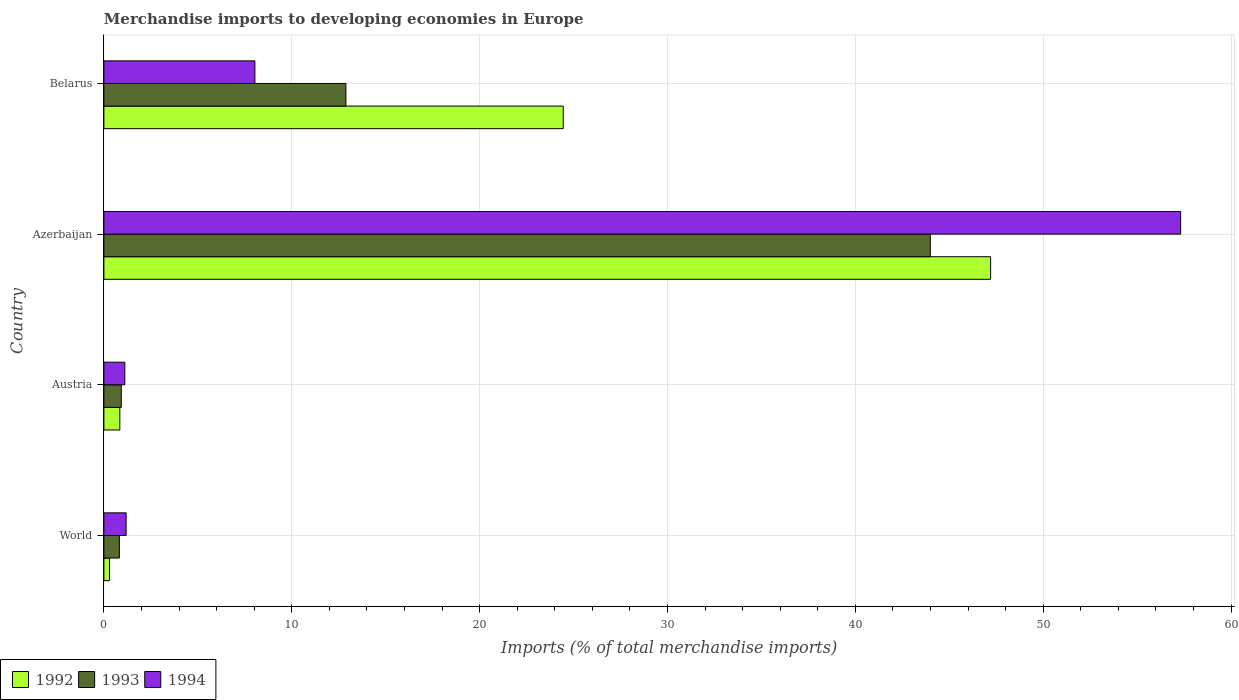How many groups of bars are there?
Make the answer very short. 4. Are the number of bars on each tick of the Y-axis equal?
Your response must be concise. Yes. How many bars are there on the 2nd tick from the top?
Provide a short and direct response. 3. How many bars are there on the 3rd tick from the bottom?
Make the answer very short. 3. In how many cases, is the number of bars for a given country not equal to the number of legend labels?
Keep it short and to the point. 0. What is the percentage total merchandise imports in 1993 in Belarus?
Keep it short and to the point. 12.88. Across all countries, what is the maximum percentage total merchandise imports in 1994?
Your answer should be compact. 57.31. Across all countries, what is the minimum percentage total merchandise imports in 1994?
Keep it short and to the point. 1.11. In which country was the percentage total merchandise imports in 1994 maximum?
Give a very brief answer. Azerbaijan. What is the total percentage total merchandise imports in 1992 in the graph?
Give a very brief answer. 72.8. What is the difference between the percentage total merchandise imports in 1993 in Azerbaijan and that in Belarus?
Offer a very short reply. 31.11. What is the difference between the percentage total merchandise imports in 1993 in Belarus and the percentage total merchandise imports in 1992 in Austria?
Your answer should be compact. 12.03. What is the average percentage total merchandise imports in 1993 per country?
Give a very brief answer. 14.65. What is the difference between the percentage total merchandise imports in 1994 and percentage total merchandise imports in 1993 in Azerbaijan?
Keep it short and to the point. 13.33. In how many countries, is the percentage total merchandise imports in 1994 greater than 8 %?
Give a very brief answer. 2. What is the ratio of the percentage total merchandise imports in 1994 in Austria to that in Azerbaijan?
Offer a very short reply. 0.02. Is the percentage total merchandise imports in 1992 in Azerbaijan less than that in Belarus?
Provide a succinct answer. No. What is the difference between the highest and the second highest percentage total merchandise imports in 1994?
Give a very brief answer. 49.28. What is the difference between the highest and the lowest percentage total merchandise imports in 1992?
Provide a succinct answer. 46.9. In how many countries, is the percentage total merchandise imports in 1994 greater than the average percentage total merchandise imports in 1994 taken over all countries?
Your answer should be very brief. 1. What does the 2nd bar from the bottom in Azerbaijan represents?
Ensure brevity in your answer.  1993. Is it the case that in every country, the sum of the percentage total merchandise imports in 1994 and percentage total merchandise imports in 1992 is greater than the percentage total merchandise imports in 1993?
Give a very brief answer. Yes. How many countries are there in the graph?
Your answer should be very brief. 4. What is the difference between two consecutive major ticks on the X-axis?
Ensure brevity in your answer.  10. Does the graph contain any zero values?
Give a very brief answer. No. Does the graph contain grids?
Provide a succinct answer. Yes. Where does the legend appear in the graph?
Provide a succinct answer. Bottom left. How many legend labels are there?
Make the answer very short. 3. How are the legend labels stacked?
Provide a short and direct response. Horizontal. What is the title of the graph?
Keep it short and to the point. Merchandise imports to developing economies in Europe. Does "1975" appear as one of the legend labels in the graph?
Your answer should be compact. No. What is the label or title of the X-axis?
Offer a very short reply. Imports (% of total merchandise imports). What is the label or title of the Y-axis?
Offer a terse response. Country. What is the Imports (% of total merchandise imports) in 1992 in World?
Offer a very short reply. 0.3. What is the Imports (% of total merchandise imports) in 1993 in World?
Give a very brief answer. 0.82. What is the Imports (% of total merchandise imports) of 1994 in World?
Provide a succinct answer. 1.18. What is the Imports (% of total merchandise imports) in 1992 in Austria?
Offer a very short reply. 0.85. What is the Imports (% of total merchandise imports) of 1993 in Austria?
Your answer should be compact. 0.93. What is the Imports (% of total merchandise imports) of 1994 in Austria?
Keep it short and to the point. 1.11. What is the Imports (% of total merchandise imports) in 1992 in Azerbaijan?
Offer a terse response. 47.2. What is the Imports (% of total merchandise imports) in 1993 in Azerbaijan?
Your response must be concise. 43.99. What is the Imports (% of total merchandise imports) of 1994 in Azerbaijan?
Provide a succinct answer. 57.31. What is the Imports (% of total merchandise imports) in 1992 in Belarus?
Your answer should be compact. 24.45. What is the Imports (% of total merchandise imports) in 1993 in Belarus?
Your answer should be very brief. 12.88. What is the Imports (% of total merchandise imports) in 1994 in Belarus?
Make the answer very short. 8.04. Across all countries, what is the maximum Imports (% of total merchandise imports) of 1992?
Offer a very short reply. 47.2. Across all countries, what is the maximum Imports (% of total merchandise imports) in 1993?
Keep it short and to the point. 43.99. Across all countries, what is the maximum Imports (% of total merchandise imports) of 1994?
Your response must be concise. 57.31. Across all countries, what is the minimum Imports (% of total merchandise imports) of 1992?
Make the answer very short. 0.3. Across all countries, what is the minimum Imports (% of total merchandise imports) of 1993?
Your answer should be very brief. 0.82. Across all countries, what is the minimum Imports (% of total merchandise imports) in 1994?
Keep it short and to the point. 1.11. What is the total Imports (% of total merchandise imports) of 1992 in the graph?
Provide a short and direct response. 72.8. What is the total Imports (% of total merchandise imports) in 1993 in the graph?
Keep it short and to the point. 58.62. What is the total Imports (% of total merchandise imports) of 1994 in the graph?
Offer a very short reply. 67.65. What is the difference between the Imports (% of total merchandise imports) of 1992 in World and that in Austria?
Your answer should be compact. -0.55. What is the difference between the Imports (% of total merchandise imports) of 1993 in World and that in Austria?
Ensure brevity in your answer.  -0.1. What is the difference between the Imports (% of total merchandise imports) of 1994 in World and that in Austria?
Ensure brevity in your answer.  0.07. What is the difference between the Imports (% of total merchandise imports) of 1992 in World and that in Azerbaijan?
Give a very brief answer. -46.9. What is the difference between the Imports (% of total merchandise imports) in 1993 in World and that in Azerbaijan?
Give a very brief answer. -43.16. What is the difference between the Imports (% of total merchandise imports) of 1994 in World and that in Azerbaijan?
Offer a very short reply. -56.13. What is the difference between the Imports (% of total merchandise imports) of 1992 in World and that in Belarus?
Make the answer very short. -24.15. What is the difference between the Imports (% of total merchandise imports) of 1993 in World and that in Belarus?
Keep it short and to the point. -12.06. What is the difference between the Imports (% of total merchandise imports) of 1994 in World and that in Belarus?
Make the answer very short. -6.85. What is the difference between the Imports (% of total merchandise imports) of 1992 in Austria and that in Azerbaijan?
Ensure brevity in your answer.  -46.35. What is the difference between the Imports (% of total merchandise imports) in 1993 in Austria and that in Azerbaijan?
Provide a succinct answer. -43.06. What is the difference between the Imports (% of total merchandise imports) in 1994 in Austria and that in Azerbaijan?
Your answer should be very brief. -56.2. What is the difference between the Imports (% of total merchandise imports) of 1992 in Austria and that in Belarus?
Give a very brief answer. -23.6. What is the difference between the Imports (% of total merchandise imports) in 1993 in Austria and that in Belarus?
Your response must be concise. -11.95. What is the difference between the Imports (% of total merchandise imports) in 1994 in Austria and that in Belarus?
Provide a succinct answer. -6.92. What is the difference between the Imports (% of total merchandise imports) in 1992 in Azerbaijan and that in Belarus?
Keep it short and to the point. 22.75. What is the difference between the Imports (% of total merchandise imports) of 1993 in Azerbaijan and that in Belarus?
Keep it short and to the point. 31.11. What is the difference between the Imports (% of total merchandise imports) of 1994 in Azerbaijan and that in Belarus?
Make the answer very short. 49.28. What is the difference between the Imports (% of total merchandise imports) of 1992 in World and the Imports (% of total merchandise imports) of 1993 in Austria?
Keep it short and to the point. -0.63. What is the difference between the Imports (% of total merchandise imports) in 1992 in World and the Imports (% of total merchandise imports) in 1994 in Austria?
Make the answer very short. -0.81. What is the difference between the Imports (% of total merchandise imports) of 1993 in World and the Imports (% of total merchandise imports) of 1994 in Austria?
Make the answer very short. -0.29. What is the difference between the Imports (% of total merchandise imports) of 1992 in World and the Imports (% of total merchandise imports) of 1993 in Azerbaijan?
Your response must be concise. -43.69. What is the difference between the Imports (% of total merchandise imports) in 1992 in World and the Imports (% of total merchandise imports) in 1994 in Azerbaijan?
Make the answer very short. -57.01. What is the difference between the Imports (% of total merchandise imports) in 1993 in World and the Imports (% of total merchandise imports) in 1994 in Azerbaijan?
Offer a very short reply. -56.49. What is the difference between the Imports (% of total merchandise imports) of 1992 in World and the Imports (% of total merchandise imports) of 1993 in Belarus?
Your response must be concise. -12.58. What is the difference between the Imports (% of total merchandise imports) in 1992 in World and the Imports (% of total merchandise imports) in 1994 in Belarus?
Provide a short and direct response. -7.74. What is the difference between the Imports (% of total merchandise imports) in 1993 in World and the Imports (% of total merchandise imports) in 1994 in Belarus?
Your answer should be very brief. -7.21. What is the difference between the Imports (% of total merchandise imports) of 1992 in Austria and the Imports (% of total merchandise imports) of 1993 in Azerbaijan?
Ensure brevity in your answer.  -43.14. What is the difference between the Imports (% of total merchandise imports) in 1992 in Austria and the Imports (% of total merchandise imports) in 1994 in Azerbaijan?
Your answer should be compact. -56.46. What is the difference between the Imports (% of total merchandise imports) of 1993 in Austria and the Imports (% of total merchandise imports) of 1994 in Azerbaijan?
Provide a short and direct response. -56.39. What is the difference between the Imports (% of total merchandise imports) of 1992 in Austria and the Imports (% of total merchandise imports) of 1993 in Belarus?
Provide a succinct answer. -12.03. What is the difference between the Imports (% of total merchandise imports) of 1992 in Austria and the Imports (% of total merchandise imports) of 1994 in Belarus?
Ensure brevity in your answer.  -7.19. What is the difference between the Imports (% of total merchandise imports) of 1993 in Austria and the Imports (% of total merchandise imports) of 1994 in Belarus?
Your answer should be very brief. -7.11. What is the difference between the Imports (% of total merchandise imports) of 1992 in Azerbaijan and the Imports (% of total merchandise imports) of 1993 in Belarus?
Offer a terse response. 34.32. What is the difference between the Imports (% of total merchandise imports) in 1992 in Azerbaijan and the Imports (% of total merchandise imports) in 1994 in Belarus?
Your answer should be very brief. 39.16. What is the difference between the Imports (% of total merchandise imports) of 1993 in Azerbaijan and the Imports (% of total merchandise imports) of 1994 in Belarus?
Ensure brevity in your answer.  35.95. What is the average Imports (% of total merchandise imports) of 1992 per country?
Make the answer very short. 18.2. What is the average Imports (% of total merchandise imports) in 1993 per country?
Make the answer very short. 14.65. What is the average Imports (% of total merchandise imports) in 1994 per country?
Make the answer very short. 16.91. What is the difference between the Imports (% of total merchandise imports) of 1992 and Imports (% of total merchandise imports) of 1993 in World?
Your response must be concise. -0.52. What is the difference between the Imports (% of total merchandise imports) of 1992 and Imports (% of total merchandise imports) of 1994 in World?
Give a very brief answer. -0.88. What is the difference between the Imports (% of total merchandise imports) in 1993 and Imports (% of total merchandise imports) in 1994 in World?
Provide a short and direct response. -0.36. What is the difference between the Imports (% of total merchandise imports) in 1992 and Imports (% of total merchandise imports) in 1993 in Austria?
Offer a terse response. -0.08. What is the difference between the Imports (% of total merchandise imports) in 1992 and Imports (% of total merchandise imports) in 1994 in Austria?
Ensure brevity in your answer.  -0.26. What is the difference between the Imports (% of total merchandise imports) in 1993 and Imports (% of total merchandise imports) in 1994 in Austria?
Offer a terse response. -0.19. What is the difference between the Imports (% of total merchandise imports) of 1992 and Imports (% of total merchandise imports) of 1993 in Azerbaijan?
Ensure brevity in your answer.  3.21. What is the difference between the Imports (% of total merchandise imports) of 1992 and Imports (% of total merchandise imports) of 1994 in Azerbaijan?
Keep it short and to the point. -10.11. What is the difference between the Imports (% of total merchandise imports) in 1993 and Imports (% of total merchandise imports) in 1994 in Azerbaijan?
Provide a short and direct response. -13.33. What is the difference between the Imports (% of total merchandise imports) in 1992 and Imports (% of total merchandise imports) in 1993 in Belarus?
Your answer should be compact. 11.57. What is the difference between the Imports (% of total merchandise imports) of 1992 and Imports (% of total merchandise imports) of 1994 in Belarus?
Offer a very short reply. 16.41. What is the difference between the Imports (% of total merchandise imports) of 1993 and Imports (% of total merchandise imports) of 1994 in Belarus?
Give a very brief answer. 4.84. What is the ratio of the Imports (% of total merchandise imports) of 1992 in World to that in Austria?
Provide a succinct answer. 0.35. What is the ratio of the Imports (% of total merchandise imports) of 1993 in World to that in Austria?
Your answer should be compact. 0.89. What is the ratio of the Imports (% of total merchandise imports) in 1994 in World to that in Austria?
Ensure brevity in your answer.  1.06. What is the ratio of the Imports (% of total merchandise imports) in 1992 in World to that in Azerbaijan?
Give a very brief answer. 0.01. What is the ratio of the Imports (% of total merchandise imports) of 1993 in World to that in Azerbaijan?
Your answer should be compact. 0.02. What is the ratio of the Imports (% of total merchandise imports) in 1994 in World to that in Azerbaijan?
Ensure brevity in your answer.  0.02. What is the ratio of the Imports (% of total merchandise imports) of 1992 in World to that in Belarus?
Provide a succinct answer. 0.01. What is the ratio of the Imports (% of total merchandise imports) in 1993 in World to that in Belarus?
Make the answer very short. 0.06. What is the ratio of the Imports (% of total merchandise imports) in 1994 in World to that in Belarus?
Your answer should be compact. 0.15. What is the ratio of the Imports (% of total merchandise imports) in 1992 in Austria to that in Azerbaijan?
Your answer should be very brief. 0.02. What is the ratio of the Imports (% of total merchandise imports) of 1993 in Austria to that in Azerbaijan?
Offer a terse response. 0.02. What is the ratio of the Imports (% of total merchandise imports) of 1994 in Austria to that in Azerbaijan?
Give a very brief answer. 0.02. What is the ratio of the Imports (% of total merchandise imports) in 1992 in Austria to that in Belarus?
Provide a short and direct response. 0.03. What is the ratio of the Imports (% of total merchandise imports) of 1993 in Austria to that in Belarus?
Offer a very short reply. 0.07. What is the ratio of the Imports (% of total merchandise imports) in 1994 in Austria to that in Belarus?
Provide a short and direct response. 0.14. What is the ratio of the Imports (% of total merchandise imports) of 1992 in Azerbaijan to that in Belarus?
Your answer should be very brief. 1.93. What is the ratio of the Imports (% of total merchandise imports) of 1993 in Azerbaijan to that in Belarus?
Provide a succinct answer. 3.42. What is the ratio of the Imports (% of total merchandise imports) of 1994 in Azerbaijan to that in Belarus?
Keep it short and to the point. 7.13. What is the difference between the highest and the second highest Imports (% of total merchandise imports) of 1992?
Offer a terse response. 22.75. What is the difference between the highest and the second highest Imports (% of total merchandise imports) in 1993?
Keep it short and to the point. 31.11. What is the difference between the highest and the second highest Imports (% of total merchandise imports) of 1994?
Ensure brevity in your answer.  49.28. What is the difference between the highest and the lowest Imports (% of total merchandise imports) of 1992?
Your answer should be compact. 46.9. What is the difference between the highest and the lowest Imports (% of total merchandise imports) of 1993?
Keep it short and to the point. 43.16. What is the difference between the highest and the lowest Imports (% of total merchandise imports) of 1994?
Offer a very short reply. 56.2. 